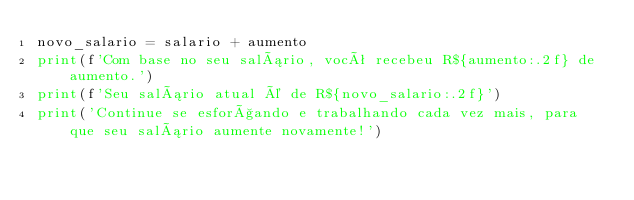<code> <loc_0><loc_0><loc_500><loc_500><_Python_>novo_salario = salario + aumento
print(f'Com base no seu salário, você recebeu R${aumento:.2f} de aumento.')
print(f'Seu salário atual é de R${novo_salario:.2f}')
print('Continue se esforçando e trabalhando cada vez mais, para que seu salário aumente novamente!')
</code> 